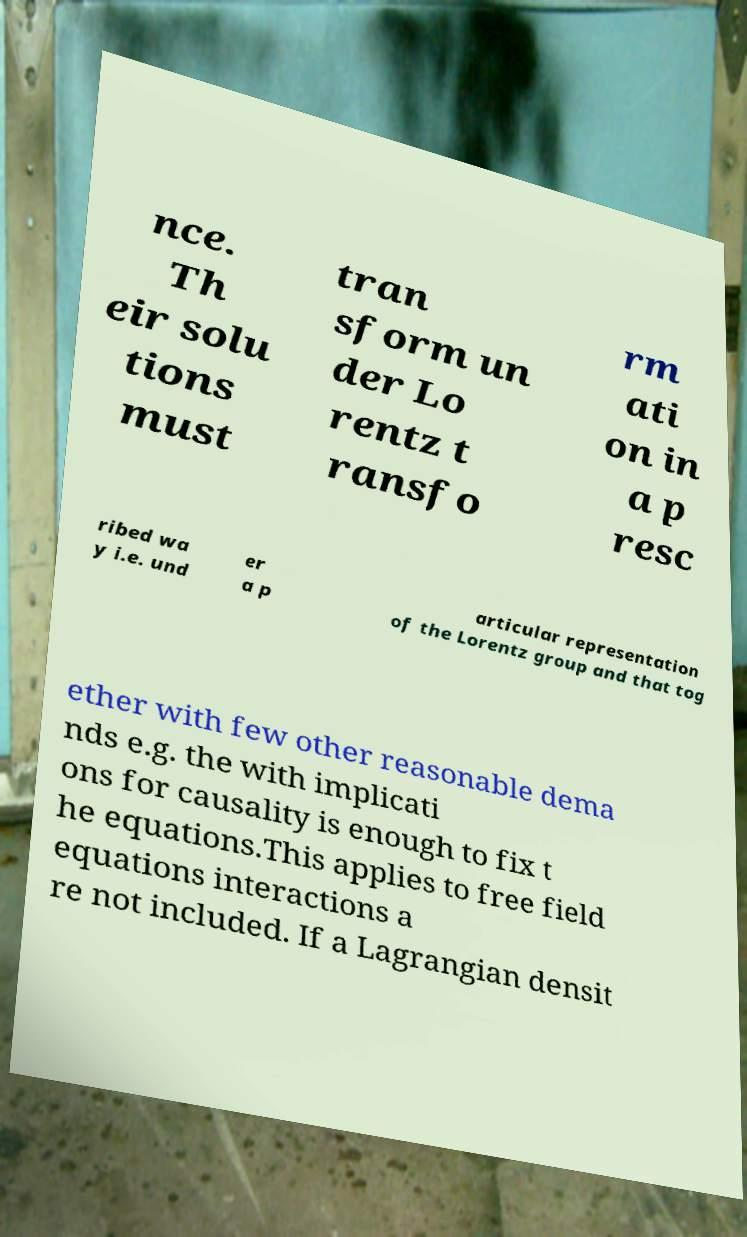Could you extract and type out the text from this image? nce. Th eir solu tions must tran sform un der Lo rentz t ransfo rm ati on in a p resc ribed wa y i.e. und er a p articular representation of the Lorentz group and that tog ether with few other reasonable dema nds e.g. the with implicati ons for causality is enough to fix t he equations.This applies to free field equations interactions a re not included. If a Lagrangian densit 